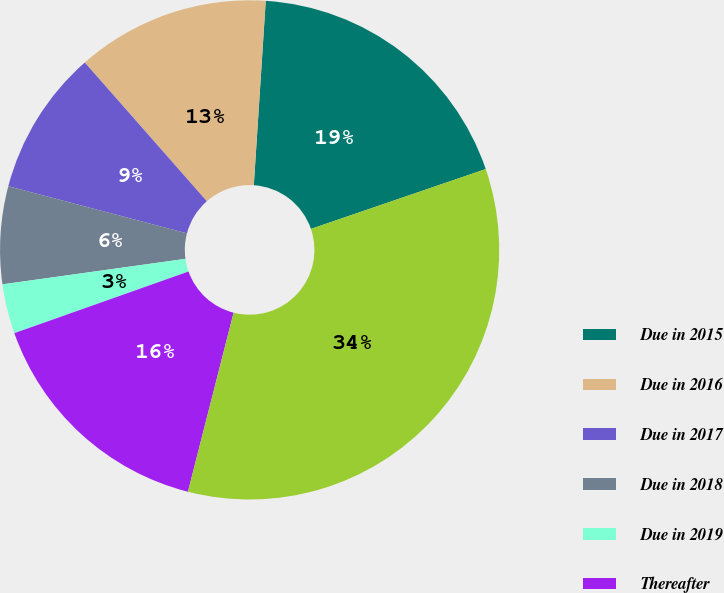Convert chart. <chart><loc_0><loc_0><loc_500><loc_500><pie_chart><fcel>Due in 2015<fcel>Due in 2016<fcel>Due in 2017<fcel>Due in 2018<fcel>Due in 2019<fcel>Thereafter<fcel>Total<nl><fcel>18.72%<fcel>12.51%<fcel>9.41%<fcel>6.31%<fcel>3.21%<fcel>15.61%<fcel>34.22%<nl></chart> 